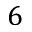<formula> <loc_0><loc_0><loc_500><loc_500>6</formula> 